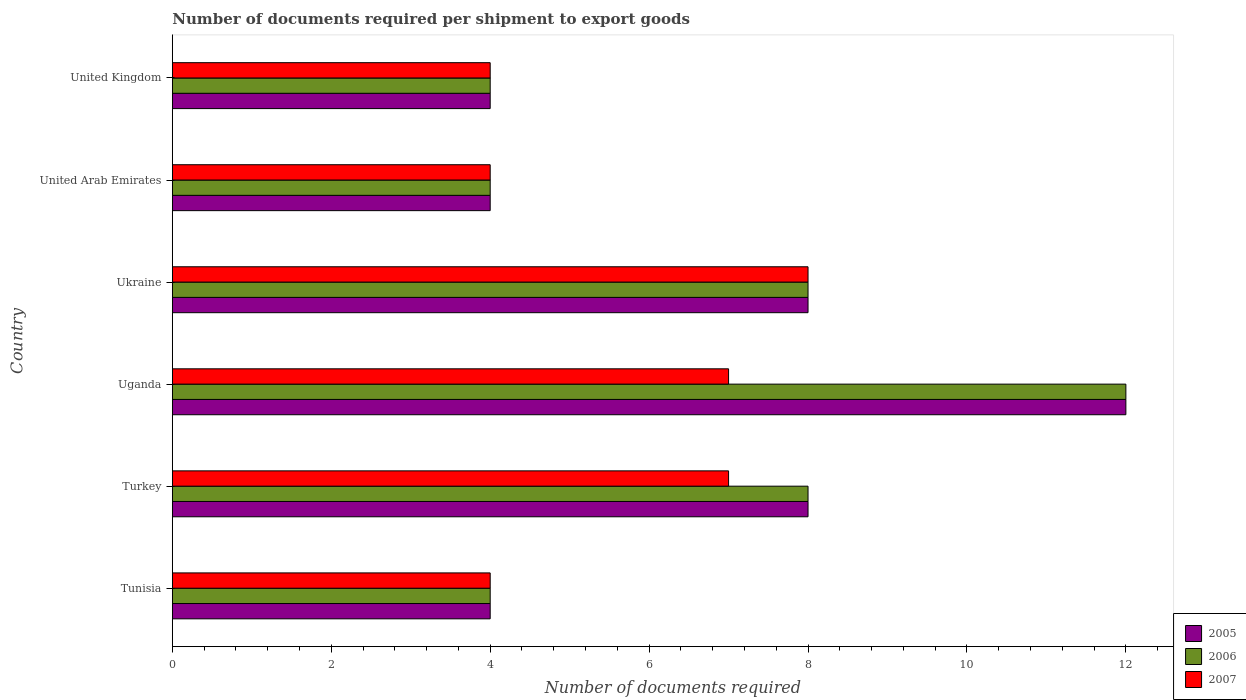Are the number of bars on each tick of the Y-axis equal?
Give a very brief answer. Yes. How many bars are there on the 5th tick from the bottom?
Your response must be concise. 3. What is the label of the 4th group of bars from the top?
Keep it short and to the point. Uganda. In how many cases, is the number of bars for a given country not equal to the number of legend labels?
Your response must be concise. 0. In which country was the number of documents required per shipment to export goods in 2007 maximum?
Ensure brevity in your answer.  Ukraine. In which country was the number of documents required per shipment to export goods in 2005 minimum?
Provide a succinct answer. Tunisia. What is the difference between the number of documents required per shipment to export goods in 2006 in Tunisia and that in United Kingdom?
Your answer should be very brief. 0. What is the average number of documents required per shipment to export goods in 2007 per country?
Give a very brief answer. 5.67. What is the difference between the number of documents required per shipment to export goods in 2006 and number of documents required per shipment to export goods in 2007 in Ukraine?
Provide a succinct answer. 0. What is the ratio of the number of documents required per shipment to export goods in 2007 in United Arab Emirates to that in United Kingdom?
Provide a succinct answer. 1. Is the number of documents required per shipment to export goods in 2007 in Tunisia less than that in Turkey?
Make the answer very short. Yes. In how many countries, is the number of documents required per shipment to export goods in 2007 greater than the average number of documents required per shipment to export goods in 2007 taken over all countries?
Provide a succinct answer. 3. Is the sum of the number of documents required per shipment to export goods in 2006 in Ukraine and United Kingdom greater than the maximum number of documents required per shipment to export goods in 2005 across all countries?
Your answer should be compact. No. What does the 1st bar from the top in United Arab Emirates represents?
Offer a terse response. 2007. What does the 2nd bar from the bottom in Ukraine represents?
Give a very brief answer. 2006. How many bars are there?
Ensure brevity in your answer.  18. What is the difference between two consecutive major ticks on the X-axis?
Offer a very short reply. 2. Are the values on the major ticks of X-axis written in scientific E-notation?
Offer a terse response. No. Does the graph contain any zero values?
Your answer should be very brief. No. Does the graph contain grids?
Your answer should be very brief. No. Where does the legend appear in the graph?
Your response must be concise. Bottom right. What is the title of the graph?
Provide a short and direct response. Number of documents required per shipment to export goods. Does "1990" appear as one of the legend labels in the graph?
Make the answer very short. No. What is the label or title of the X-axis?
Give a very brief answer. Number of documents required. What is the Number of documents required in 2005 in Tunisia?
Provide a succinct answer. 4. What is the Number of documents required in 2006 in Tunisia?
Provide a short and direct response. 4. What is the Number of documents required in 2007 in Tunisia?
Provide a succinct answer. 4. What is the Number of documents required in 2005 in Turkey?
Provide a succinct answer. 8. What is the Number of documents required in 2005 in Uganda?
Your response must be concise. 12. What is the Number of documents required of 2006 in Ukraine?
Your response must be concise. 8. What is the Number of documents required of 2007 in Ukraine?
Offer a terse response. 8. What is the Number of documents required in 2005 in United Arab Emirates?
Offer a very short reply. 4. What is the Number of documents required of 2006 in United Arab Emirates?
Your response must be concise. 4. What is the Number of documents required of 2007 in United Arab Emirates?
Give a very brief answer. 4. What is the Number of documents required in 2005 in United Kingdom?
Make the answer very short. 4. What is the Number of documents required of 2007 in United Kingdom?
Ensure brevity in your answer.  4. Across all countries, what is the maximum Number of documents required of 2006?
Your answer should be compact. 12. Across all countries, what is the maximum Number of documents required in 2007?
Keep it short and to the point. 8. What is the total Number of documents required in 2006 in the graph?
Provide a short and direct response. 40. What is the total Number of documents required of 2007 in the graph?
Ensure brevity in your answer.  34. What is the difference between the Number of documents required in 2005 in Tunisia and that in Turkey?
Your answer should be very brief. -4. What is the difference between the Number of documents required of 2005 in Tunisia and that in Uganda?
Your answer should be compact. -8. What is the difference between the Number of documents required of 2007 in Tunisia and that in Uganda?
Give a very brief answer. -3. What is the difference between the Number of documents required in 2006 in Tunisia and that in Ukraine?
Provide a short and direct response. -4. What is the difference between the Number of documents required in 2007 in Tunisia and that in Ukraine?
Make the answer very short. -4. What is the difference between the Number of documents required in 2005 in Tunisia and that in United Arab Emirates?
Ensure brevity in your answer.  0. What is the difference between the Number of documents required in 2006 in Tunisia and that in United Kingdom?
Keep it short and to the point. 0. What is the difference between the Number of documents required in 2007 in Tunisia and that in United Kingdom?
Keep it short and to the point. 0. What is the difference between the Number of documents required in 2005 in Turkey and that in Uganda?
Offer a very short reply. -4. What is the difference between the Number of documents required of 2006 in Turkey and that in Uganda?
Provide a succinct answer. -4. What is the difference between the Number of documents required in 2006 in Turkey and that in Ukraine?
Keep it short and to the point. 0. What is the difference between the Number of documents required in 2006 in Turkey and that in United Kingdom?
Give a very brief answer. 4. What is the difference between the Number of documents required in 2007 in Turkey and that in United Kingdom?
Your answer should be very brief. 3. What is the difference between the Number of documents required in 2005 in Uganda and that in Ukraine?
Offer a terse response. 4. What is the difference between the Number of documents required of 2005 in Uganda and that in United Arab Emirates?
Offer a very short reply. 8. What is the difference between the Number of documents required in 2005 in Uganda and that in United Kingdom?
Keep it short and to the point. 8. What is the difference between the Number of documents required of 2007 in Uganda and that in United Kingdom?
Provide a short and direct response. 3. What is the difference between the Number of documents required in 2005 in Ukraine and that in United Arab Emirates?
Give a very brief answer. 4. What is the difference between the Number of documents required in 2006 in Ukraine and that in United Arab Emirates?
Your answer should be very brief. 4. What is the difference between the Number of documents required of 2007 in Ukraine and that in United Arab Emirates?
Your response must be concise. 4. What is the difference between the Number of documents required of 2005 in Ukraine and that in United Kingdom?
Make the answer very short. 4. What is the difference between the Number of documents required in 2007 in Ukraine and that in United Kingdom?
Your answer should be compact. 4. What is the difference between the Number of documents required of 2005 in United Arab Emirates and that in United Kingdom?
Provide a short and direct response. 0. What is the difference between the Number of documents required in 2007 in United Arab Emirates and that in United Kingdom?
Make the answer very short. 0. What is the difference between the Number of documents required in 2005 in Tunisia and the Number of documents required in 2007 in Turkey?
Make the answer very short. -3. What is the difference between the Number of documents required of 2006 in Tunisia and the Number of documents required of 2007 in Turkey?
Give a very brief answer. -3. What is the difference between the Number of documents required of 2005 in Tunisia and the Number of documents required of 2007 in Uganda?
Give a very brief answer. -3. What is the difference between the Number of documents required of 2005 in Tunisia and the Number of documents required of 2007 in United Arab Emirates?
Your answer should be compact. 0. What is the difference between the Number of documents required of 2006 in Tunisia and the Number of documents required of 2007 in United Arab Emirates?
Your answer should be compact. 0. What is the difference between the Number of documents required in 2005 in Tunisia and the Number of documents required in 2007 in United Kingdom?
Keep it short and to the point. 0. What is the difference between the Number of documents required in 2005 in Turkey and the Number of documents required in 2007 in Uganda?
Give a very brief answer. 1. What is the difference between the Number of documents required in 2006 in Turkey and the Number of documents required in 2007 in Uganda?
Provide a short and direct response. 1. What is the difference between the Number of documents required in 2005 in Turkey and the Number of documents required in 2006 in Ukraine?
Your answer should be very brief. 0. What is the difference between the Number of documents required in 2005 in Turkey and the Number of documents required in 2007 in United Arab Emirates?
Give a very brief answer. 4. What is the difference between the Number of documents required of 2006 in Turkey and the Number of documents required of 2007 in United Kingdom?
Keep it short and to the point. 4. What is the difference between the Number of documents required in 2005 in Uganda and the Number of documents required in 2006 in United Arab Emirates?
Your answer should be very brief. 8. What is the difference between the Number of documents required of 2006 in Uganda and the Number of documents required of 2007 in United Kingdom?
Offer a very short reply. 8. What is the difference between the Number of documents required in 2005 in Ukraine and the Number of documents required in 2006 in United Arab Emirates?
Your answer should be very brief. 4. What is the difference between the Number of documents required in 2005 in Ukraine and the Number of documents required in 2007 in United Arab Emirates?
Offer a very short reply. 4. What is the difference between the Number of documents required in 2006 in Ukraine and the Number of documents required in 2007 in United Arab Emirates?
Your answer should be compact. 4. What is the difference between the Number of documents required in 2005 in United Arab Emirates and the Number of documents required in 2007 in United Kingdom?
Keep it short and to the point. 0. What is the difference between the Number of documents required in 2006 in United Arab Emirates and the Number of documents required in 2007 in United Kingdom?
Keep it short and to the point. 0. What is the average Number of documents required of 2005 per country?
Provide a succinct answer. 6.67. What is the average Number of documents required in 2007 per country?
Ensure brevity in your answer.  5.67. What is the difference between the Number of documents required of 2005 and Number of documents required of 2007 in Tunisia?
Keep it short and to the point. 0. What is the difference between the Number of documents required of 2005 and Number of documents required of 2007 in Uganda?
Your response must be concise. 5. What is the difference between the Number of documents required of 2005 and Number of documents required of 2006 in Ukraine?
Offer a terse response. 0. What is the difference between the Number of documents required in 2005 and Number of documents required in 2007 in Ukraine?
Keep it short and to the point. 0. What is the difference between the Number of documents required in 2005 and Number of documents required in 2007 in United Arab Emirates?
Give a very brief answer. 0. What is the difference between the Number of documents required of 2006 and Number of documents required of 2007 in United Arab Emirates?
Offer a terse response. 0. What is the difference between the Number of documents required in 2005 and Number of documents required in 2007 in United Kingdom?
Offer a terse response. 0. What is the ratio of the Number of documents required in 2006 in Tunisia to that in Turkey?
Your response must be concise. 0.5. What is the ratio of the Number of documents required of 2007 in Tunisia to that in Turkey?
Provide a short and direct response. 0.57. What is the ratio of the Number of documents required of 2006 in Tunisia to that in Ukraine?
Make the answer very short. 0.5. What is the ratio of the Number of documents required in 2007 in Tunisia to that in Ukraine?
Provide a succinct answer. 0.5. What is the ratio of the Number of documents required in 2005 in Tunisia to that in United Arab Emirates?
Provide a succinct answer. 1. What is the ratio of the Number of documents required of 2006 in Tunisia to that in United Kingdom?
Your answer should be very brief. 1. What is the ratio of the Number of documents required of 2007 in Tunisia to that in United Kingdom?
Make the answer very short. 1. What is the ratio of the Number of documents required in 2005 in Turkey to that in Uganda?
Make the answer very short. 0.67. What is the ratio of the Number of documents required of 2006 in Turkey to that in Uganda?
Your answer should be compact. 0.67. What is the ratio of the Number of documents required in 2006 in Turkey to that in United Kingdom?
Ensure brevity in your answer.  2. What is the ratio of the Number of documents required of 2006 in Uganda to that in Ukraine?
Your response must be concise. 1.5. What is the ratio of the Number of documents required in 2007 in Uganda to that in Ukraine?
Make the answer very short. 0.88. What is the ratio of the Number of documents required of 2007 in Uganda to that in United Arab Emirates?
Make the answer very short. 1.75. What is the ratio of the Number of documents required of 2006 in Ukraine to that in United Arab Emirates?
Your response must be concise. 2. What is the ratio of the Number of documents required of 2007 in Ukraine to that in United Arab Emirates?
Give a very brief answer. 2. What is the ratio of the Number of documents required of 2005 in United Arab Emirates to that in United Kingdom?
Provide a short and direct response. 1. What is the difference between the highest and the second highest Number of documents required of 2007?
Offer a terse response. 1. 